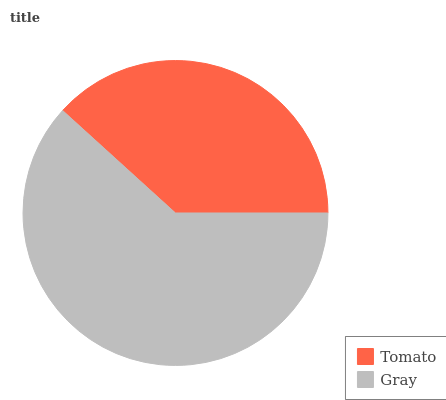Is Tomato the minimum?
Answer yes or no. Yes. Is Gray the maximum?
Answer yes or no. Yes. Is Gray the minimum?
Answer yes or no. No. Is Gray greater than Tomato?
Answer yes or no. Yes. Is Tomato less than Gray?
Answer yes or no. Yes. Is Tomato greater than Gray?
Answer yes or no. No. Is Gray less than Tomato?
Answer yes or no. No. Is Gray the high median?
Answer yes or no. Yes. Is Tomato the low median?
Answer yes or no. Yes. Is Tomato the high median?
Answer yes or no. No. Is Gray the low median?
Answer yes or no. No. 